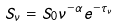<formula> <loc_0><loc_0><loc_500><loc_500>S _ { \nu } = S _ { 0 } \nu ^ { - \alpha } e ^ { - \tau _ { \nu } }</formula> 